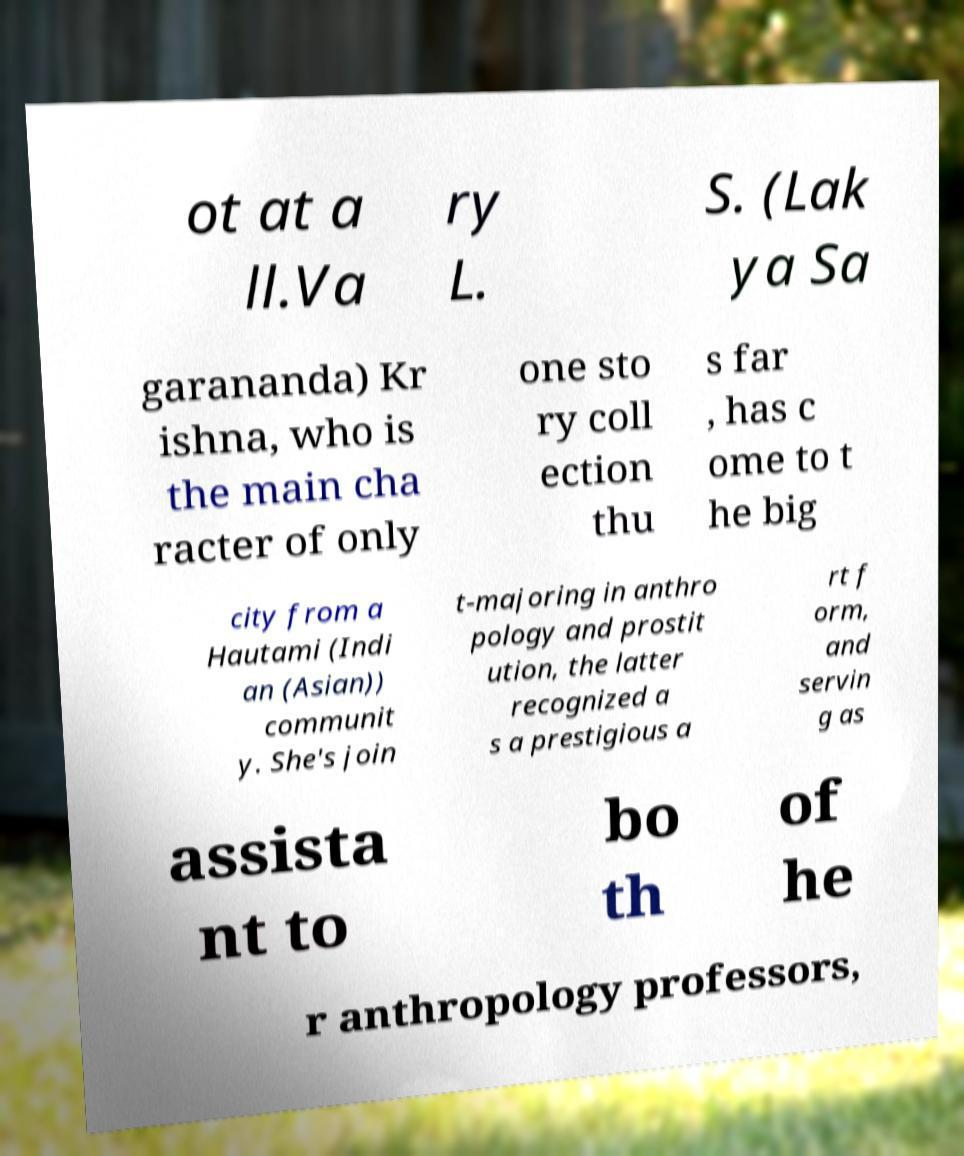There's text embedded in this image that I need extracted. Can you transcribe it verbatim? ot at a ll.Va ry L. S. (Lak ya Sa garananda) Kr ishna, who is the main cha racter of only one sto ry coll ection thu s far , has c ome to t he big city from a Hautami (Indi an (Asian)) communit y. She's join t-majoring in anthro pology and prostit ution, the latter recognized a s a prestigious a rt f orm, and servin g as assista nt to bo th of he r anthropology professors, 